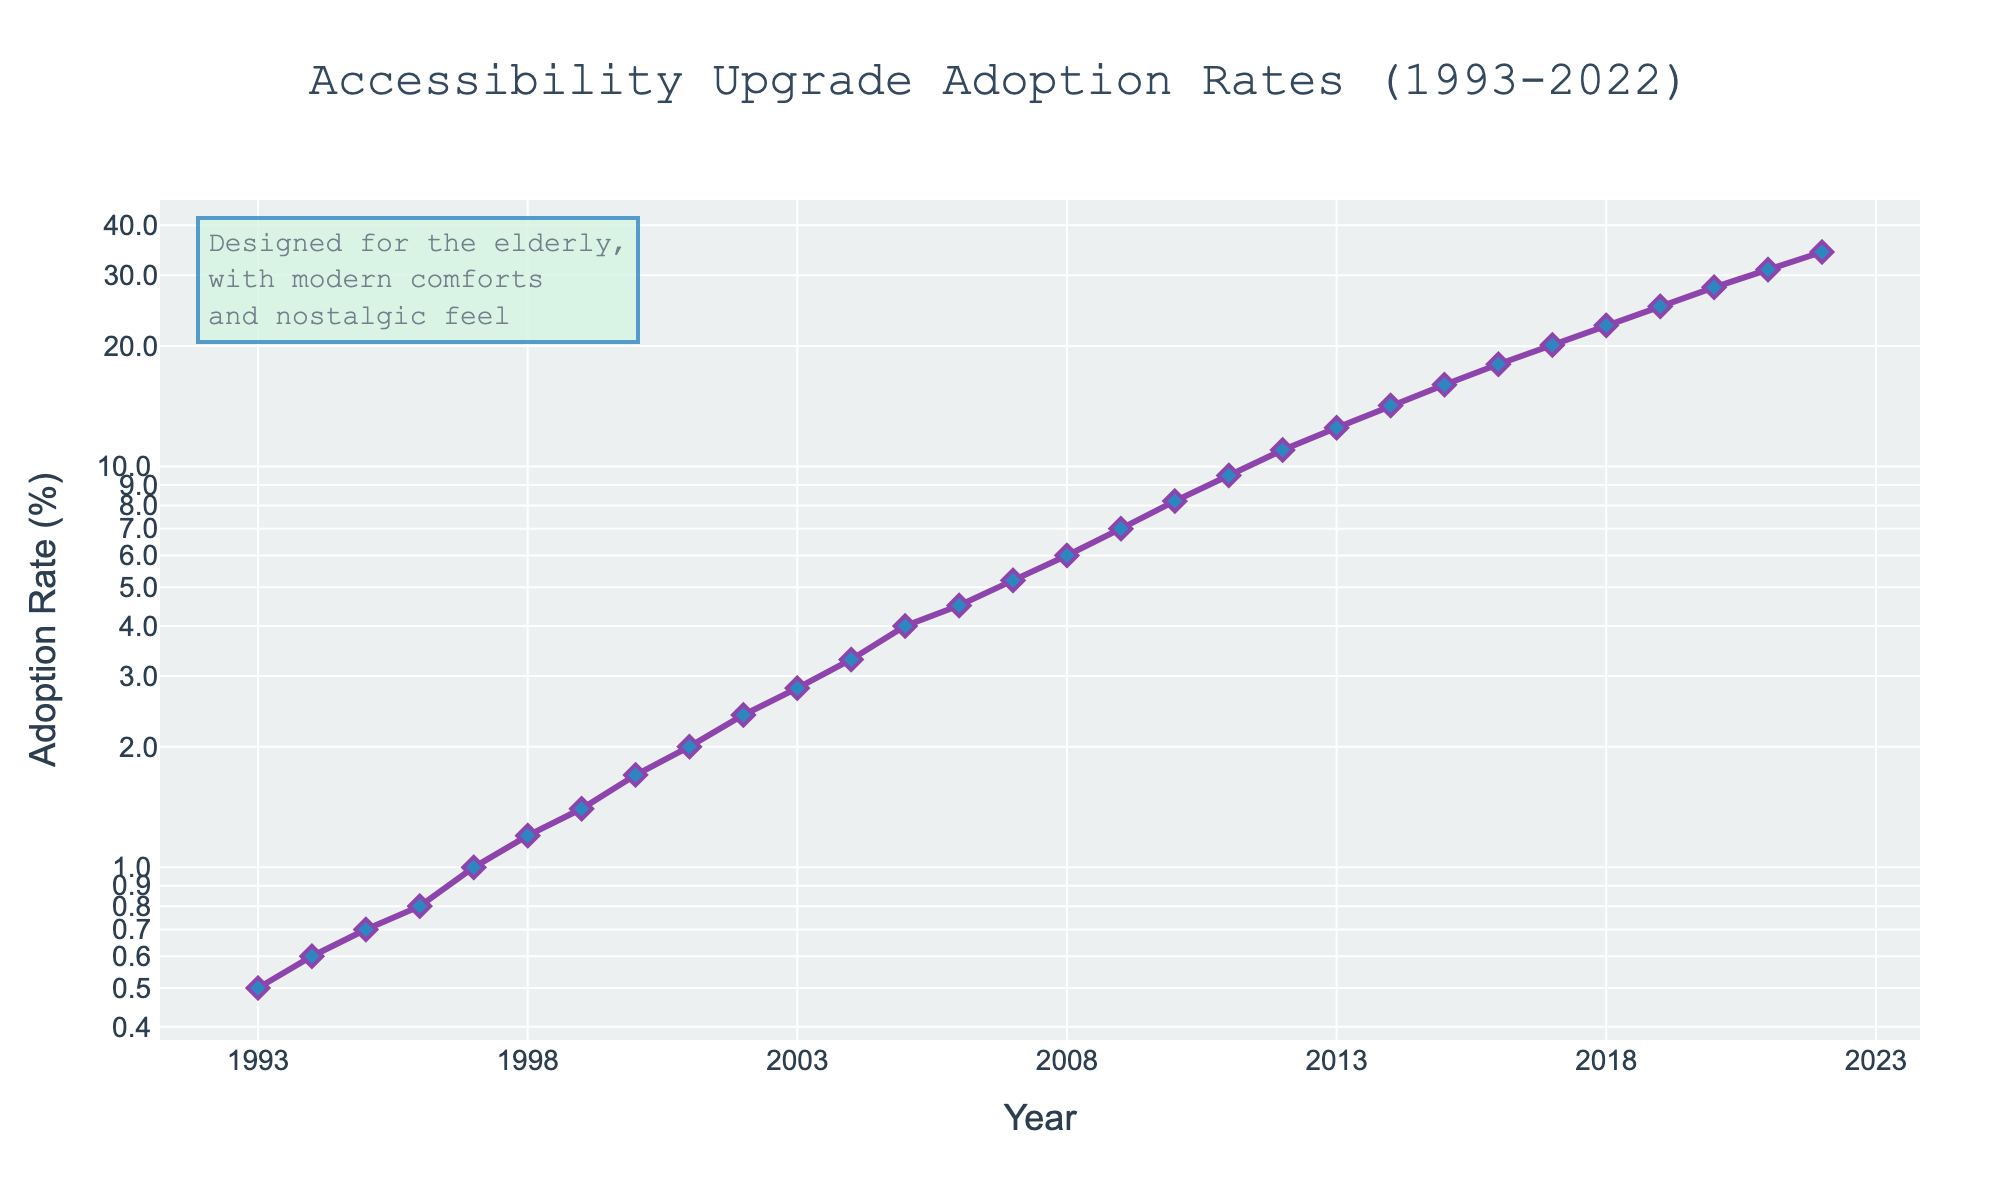What's the title of the graph? The title of the graph is displayed at the top center of the figure.
Answer: Accessibility Upgrade Adoption Rates (1993-2022) What is the color of the line in the graph? The line in the graph is colored in a specific shade. By looking at the plot, you can see its color.
Answer: Purple How many data points are there in total? Each data point represents a single year from 1993 to 2022. The number of data points is the total number of years depicted in the graph.
Answer: 30 What was the adoption rate in 2000? Locate the year 2000 on the x-axis and then observe the corresponding y-axis value.
Answer: 1.7% Between which years did the adoption rate first exceed 10%? Observe the y-axis for the first instance where the value surpasses 10% and then match it to the corresponding year on the x-axis.
Answer: 2012 and 2013 During which period did the adoption rate see the most rapid increase? Identify the steepest part of the line on the graph, which corresponds to the period with the most rapid increase.
Answer: 1993-2022, overall increase What was the growth in adoption rate from 1993 to 1998? Subtract the adoption rate in 1993 from the adoption rate in 1998 to get the growth. 1.2% - 0.5% = 0.7%
Answer: 0.7% What's the average adoption rate over the decades? Group the data into three decades, sum the adoption rates in each decade, and divide by the number of years in each decade.
Answer: ≈ 2.42% (1993-2002), ≈ 6.97% (2003-2012), ≈ 17.60% (2013-2022) What is the adoption rate's trend over the last three decades? Observe the overall direction and shape of the line on the graph across the specified period. The trend can be identified by looking at the consistent increase or decrease over time.
Answer: Increasing trend Which year had an adoption rate closest to 10%? Locate the year in which the y-axis value is closest to 10%.
Answer: 2011 